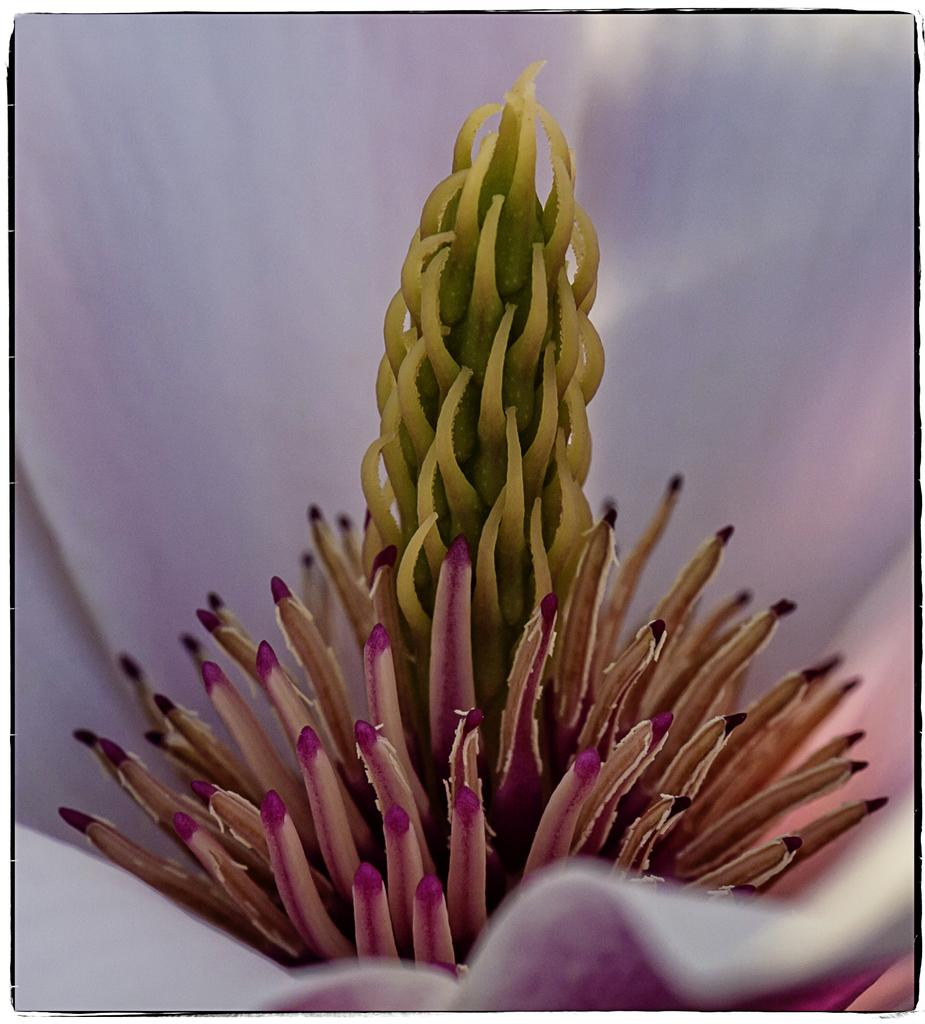What is the main subject of the image? The main subject of the image is an inside view of a flower. What can be seen within the flower? There are pollen grains visible in the image. What part of the flower is located in the middle? There is a stigma present in the middle of the flower. What rules apply to the competition between the pollen grains in the image? There is no competition between pollen grains in the image, as they are simply visible within the flower. 